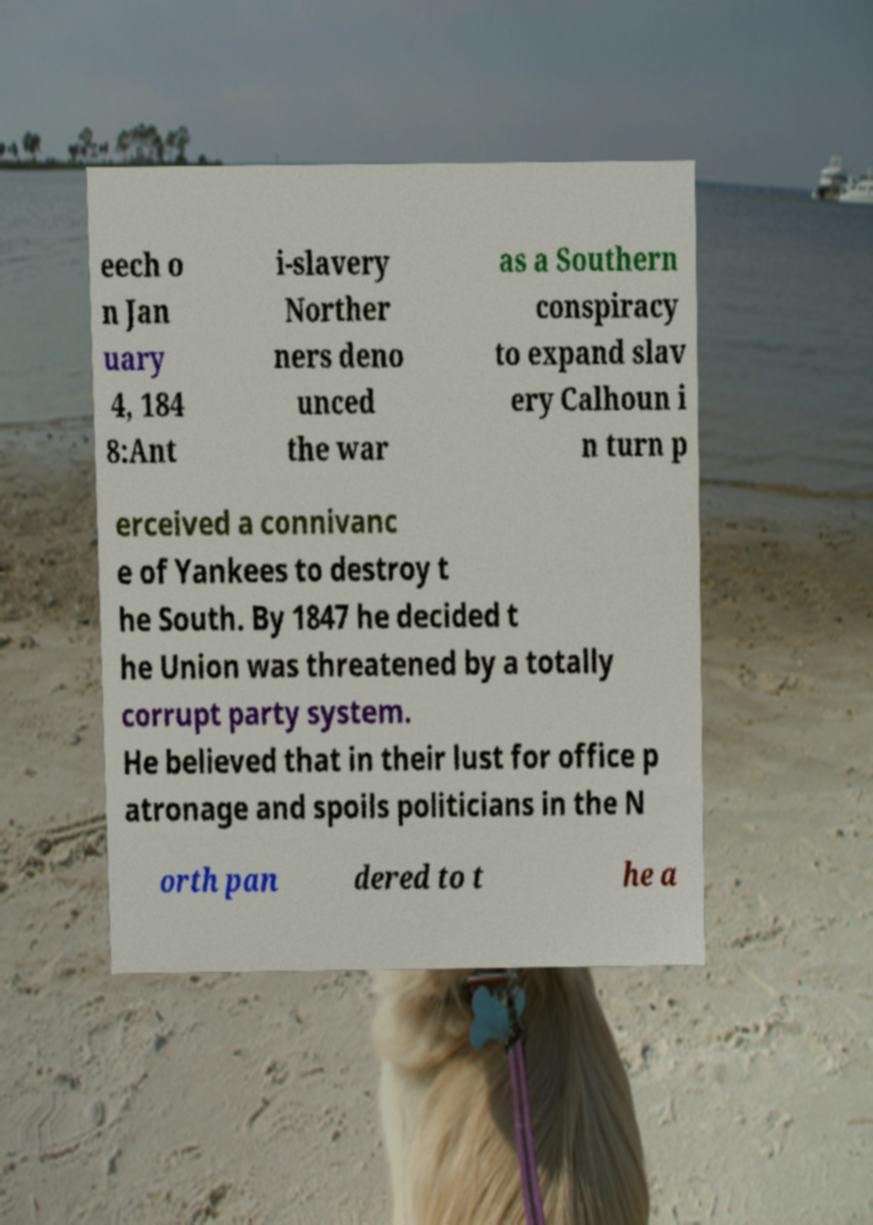Please read and relay the text visible in this image. What does it say? eech o n Jan uary 4, 184 8:Ant i-slavery Norther ners deno unced the war as a Southern conspiracy to expand slav ery Calhoun i n turn p erceived a connivanc e of Yankees to destroy t he South. By 1847 he decided t he Union was threatened by a totally corrupt party system. He believed that in their lust for office p atronage and spoils politicians in the N orth pan dered to t he a 